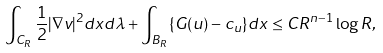<formula> <loc_0><loc_0><loc_500><loc_500>\int _ { C _ { R } } \frac { 1 } { 2 } | \nabla v | ^ { 2 } d x d \lambda + \int _ { B _ { R } } \{ G ( u ) - c _ { u } \} d x \leq C R ^ { n - 1 } \log R ,</formula> 